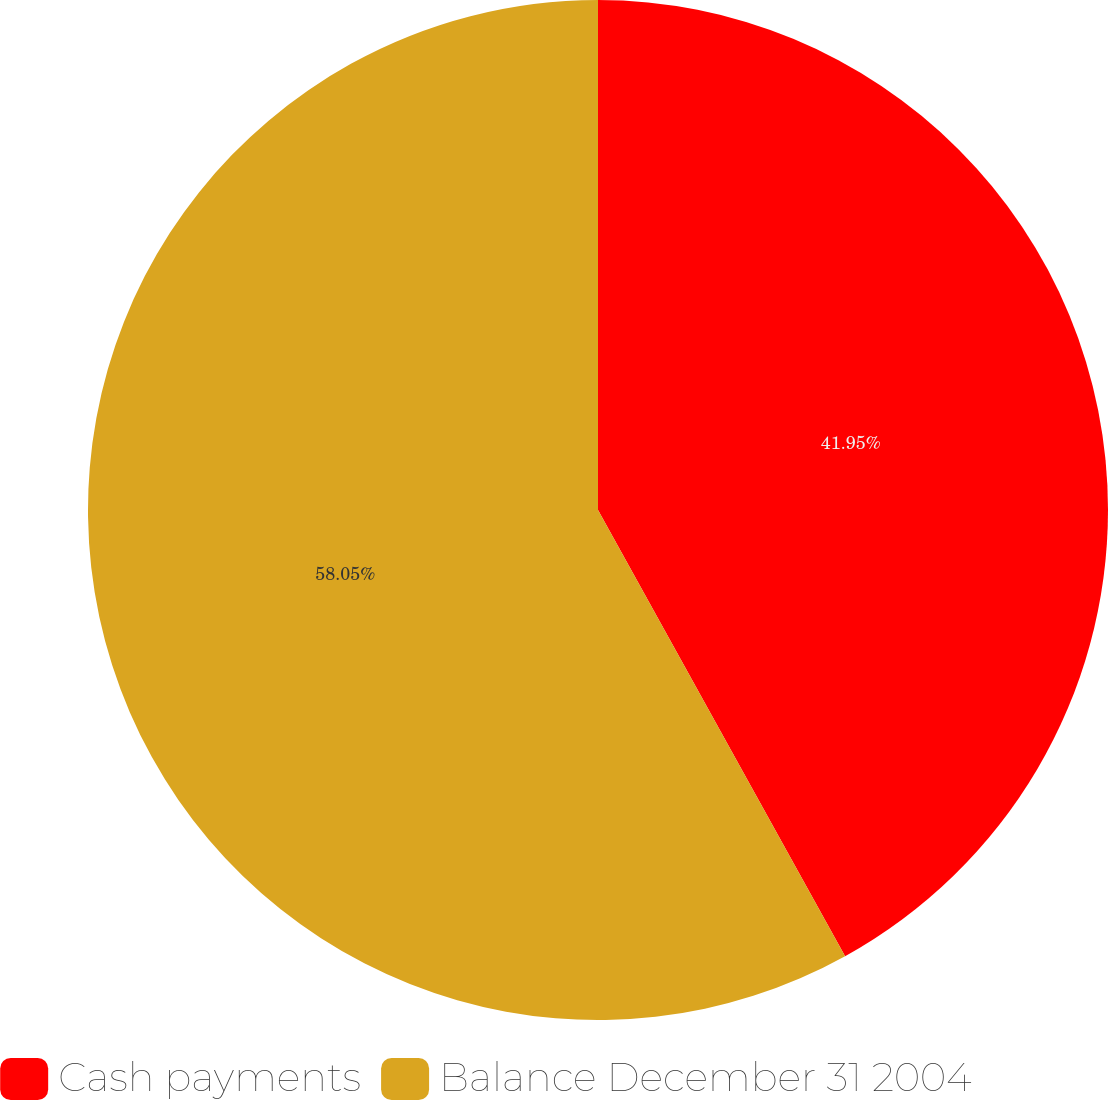Convert chart to OTSL. <chart><loc_0><loc_0><loc_500><loc_500><pie_chart><fcel>Cash payments<fcel>Balance December 31 2004<nl><fcel>41.95%<fcel>58.05%<nl></chart> 